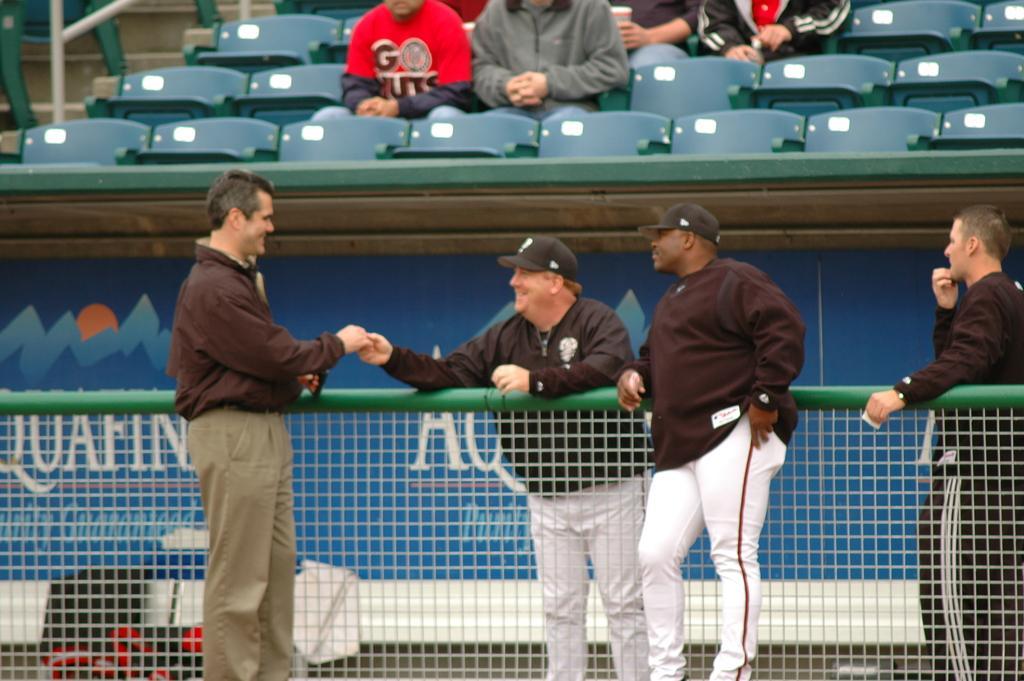How would you summarize this image in a sentence or two? This image is taken in a stadium. At the bottom of the image there is a net. In the middle of the image four men are standing on the ground and there is a board with a text on it. At the top of the image a few people are sitting on the chairs and there are many empty chairs and there is a railing. 